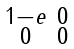<formula> <loc_0><loc_0><loc_500><loc_500>\begin{smallmatrix} 1 - e & 0 \\ 0 & 0 \end{smallmatrix}</formula> 